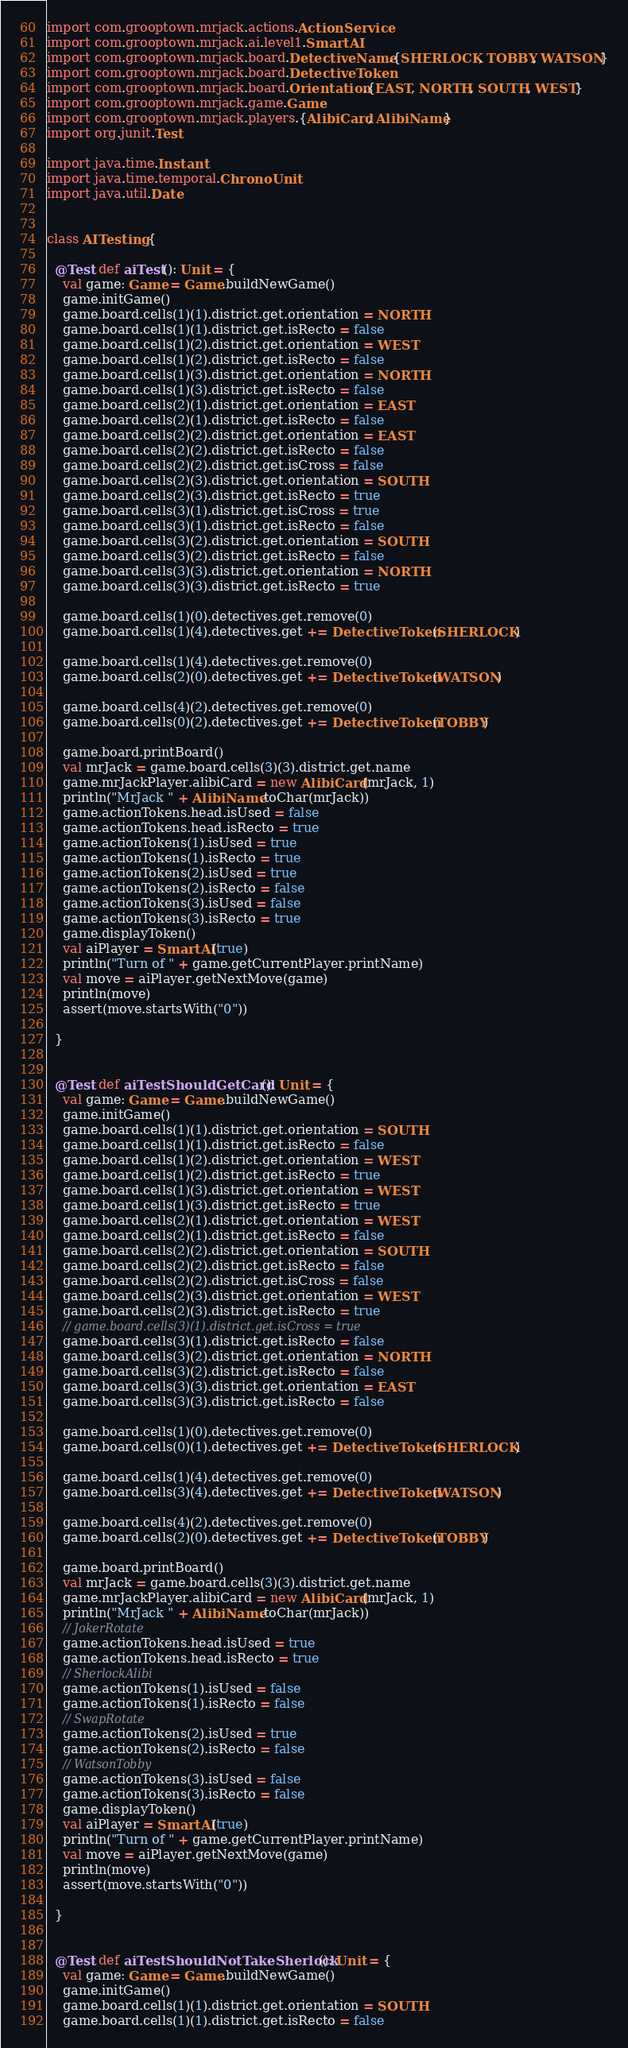Convert code to text. <code><loc_0><loc_0><loc_500><loc_500><_Scala_>import com.grooptown.mrjack.actions.ActionService
import com.grooptown.mrjack.ai.level1.SmartAI
import com.grooptown.mrjack.board.DetectiveName.{SHERLOCK, TOBBY, WATSON}
import com.grooptown.mrjack.board.DetectiveToken
import com.grooptown.mrjack.board.Orientation.{EAST, NORTH, SOUTH, WEST}
import com.grooptown.mrjack.game.Game
import com.grooptown.mrjack.players.{AlibiCard, AlibiName}
import org.junit.Test

import java.time.Instant
import java.time.temporal.ChronoUnit
import java.util.Date


class AITesting {

  @Test def aiTest(): Unit = {
    val game: Game = Game.buildNewGame()
    game.initGame()
    game.board.cells(1)(1).district.get.orientation = NORTH
    game.board.cells(1)(1).district.get.isRecto = false
    game.board.cells(1)(2).district.get.orientation = WEST
    game.board.cells(1)(2).district.get.isRecto = false
    game.board.cells(1)(3).district.get.orientation = NORTH
    game.board.cells(1)(3).district.get.isRecto = false
    game.board.cells(2)(1).district.get.orientation = EAST
    game.board.cells(2)(1).district.get.isRecto = false
    game.board.cells(2)(2).district.get.orientation = EAST
    game.board.cells(2)(2).district.get.isRecto = false
    game.board.cells(2)(2).district.get.isCross = false
    game.board.cells(2)(3).district.get.orientation = SOUTH
    game.board.cells(2)(3).district.get.isRecto = true
    game.board.cells(3)(1).district.get.isCross = true
    game.board.cells(3)(1).district.get.isRecto = false
    game.board.cells(3)(2).district.get.orientation = SOUTH
    game.board.cells(3)(2).district.get.isRecto = false
    game.board.cells(3)(3).district.get.orientation = NORTH
    game.board.cells(3)(3).district.get.isRecto = true

    game.board.cells(1)(0).detectives.get.remove(0)
    game.board.cells(1)(4).detectives.get += DetectiveToken(SHERLOCK)

    game.board.cells(1)(4).detectives.get.remove(0)
    game.board.cells(2)(0).detectives.get += DetectiveToken(WATSON)

    game.board.cells(4)(2).detectives.get.remove(0)
    game.board.cells(0)(2).detectives.get += DetectiveToken(TOBBY)

    game.board.printBoard()
    val mrJack = game.board.cells(3)(3).district.get.name
    game.mrJackPlayer.alibiCard = new AlibiCard(mrJack, 1)
    println("MrJack " + AlibiName.toChar(mrJack))
    game.actionTokens.head.isUsed = false
    game.actionTokens.head.isRecto = true
    game.actionTokens(1).isUsed = true
    game.actionTokens(1).isRecto = true
    game.actionTokens(2).isUsed = true
    game.actionTokens(2).isRecto = false
    game.actionTokens(3).isUsed = false
    game.actionTokens(3).isRecto = true
    game.displayToken()
    val aiPlayer = SmartAI(true)
    println("Turn of " + game.getCurrentPlayer.printName)
    val move = aiPlayer.getNextMove(game)
    println(move)
    assert(move.startsWith("0"))

  }


  @Test def aiTestShouldGetCard(): Unit = {
    val game: Game = Game.buildNewGame()
    game.initGame()
    game.board.cells(1)(1).district.get.orientation = SOUTH
    game.board.cells(1)(1).district.get.isRecto = false
    game.board.cells(1)(2).district.get.orientation = WEST
    game.board.cells(1)(2).district.get.isRecto = true
    game.board.cells(1)(3).district.get.orientation = WEST
    game.board.cells(1)(3).district.get.isRecto = true
    game.board.cells(2)(1).district.get.orientation = WEST
    game.board.cells(2)(1).district.get.isRecto = false
    game.board.cells(2)(2).district.get.orientation = SOUTH
    game.board.cells(2)(2).district.get.isRecto = false
    game.board.cells(2)(2).district.get.isCross = false
    game.board.cells(2)(3).district.get.orientation = WEST
    game.board.cells(2)(3).district.get.isRecto = true
    // game.board.cells(3)(1).district.get.isCross = true
    game.board.cells(3)(1).district.get.isRecto = false
    game.board.cells(3)(2).district.get.orientation = NORTH
    game.board.cells(3)(2).district.get.isRecto = false
    game.board.cells(3)(3).district.get.orientation = EAST
    game.board.cells(3)(3).district.get.isRecto = false

    game.board.cells(1)(0).detectives.get.remove(0)
    game.board.cells(0)(1).detectives.get += DetectiveToken(SHERLOCK)

    game.board.cells(1)(4).detectives.get.remove(0)
    game.board.cells(3)(4).detectives.get += DetectiveToken(WATSON)

    game.board.cells(4)(2).detectives.get.remove(0)
    game.board.cells(2)(0).detectives.get += DetectiveToken(TOBBY)

    game.board.printBoard()
    val mrJack = game.board.cells(3)(3).district.get.name
    game.mrJackPlayer.alibiCard = new AlibiCard(mrJack, 1)
    println("MrJack " + AlibiName.toChar(mrJack))
    // JokerRotate
    game.actionTokens.head.isUsed = true
    game.actionTokens.head.isRecto = true
    // SherlockAlibi
    game.actionTokens(1).isUsed = false
    game.actionTokens(1).isRecto = false
    // SwapRotate
    game.actionTokens(2).isUsed = true
    game.actionTokens(2).isRecto = false
    // WatsonTobby
    game.actionTokens(3).isUsed = false
    game.actionTokens(3).isRecto = false
    game.displayToken()
    val aiPlayer = SmartAI(true)
    println("Turn of " + game.getCurrentPlayer.printName)
    val move = aiPlayer.getNextMove(game)
    println(move)
    assert(move.startsWith("0"))

  }


  @Test def aiTestShouldNotTakeSherlock(): Unit = {
    val game: Game = Game.buildNewGame()
    game.initGame()
    game.board.cells(1)(1).district.get.orientation = SOUTH
    game.board.cells(1)(1).district.get.isRecto = false</code> 